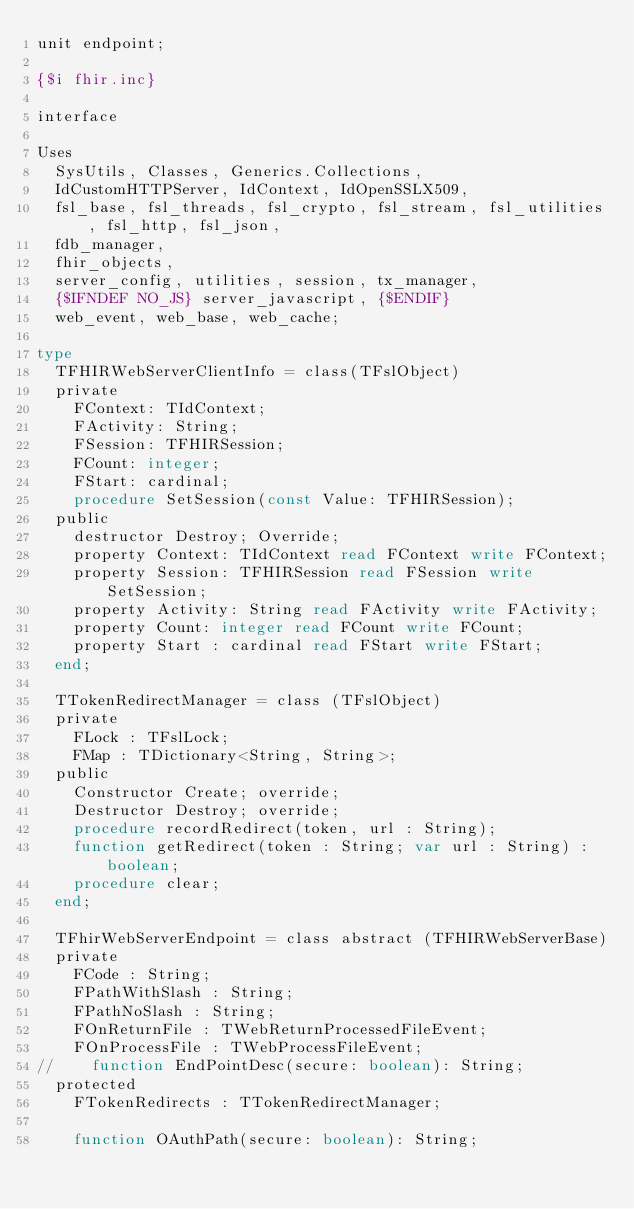<code> <loc_0><loc_0><loc_500><loc_500><_Pascal_>unit endpoint;

{$i fhir.inc}

interface

Uses
  SysUtils, Classes, Generics.Collections,
  IdCustomHTTPServer, IdContext, IdOpenSSLX509,
  fsl_base, fsl_threads, fsl_crypto, fsl_stream, fsl_utilities, fsl_http, fsl_json,
  fdb_manager,
  fhir_objects,
  server_config, utilities, session, tx_manager,
  {$IFNDEF NO_JS} server_javascript, {$ENDIF}
  web_event, web_base, web_cache;

type
  TFHIRWebServerClientInfo = class(TFslObject)
  private
    FContext: TIdContext;
    FActivity: String;
    FSession: TFHIRSession;
    FCount: integer;
    FStart: cardinal;
    procedure SetSession(const Value: TFHIRSession);
  public
    destructor Destroy; Override;
    property Context: TIdContext read FContext write FContext;
    property Session: TFHIRSession read FSession write SetSession;
    property Activity: String read FActivity write FActivity;
    property Count: integer read FCount write FCount;
    property Start : cardinal read FStart write FStart;
  end;

  TTokenRedirectManager = class (TFslObject)
  private
    FLock : TFslLock;
    FMap : TDictionary<String, String>;
  public
    Constructor Create; override;
    Destructor Destroy; override;
    procedure recordRedirect(token, url : String);
    function getRedirect(token : String; var url : String) : boolean;
    procedure clear;
  end;

  TFhirWebServerEndpoint = class abstract (TFHIRWebServerBase)
  private
    FCode : String;
    FPathWithSlash : String;
    FPathNoSlash : String;
    FOnReturnFile : TWebReturnProcessedFileEvent;
    FOnProcessFile : TWebProcessFileEvent;
//    function EndPointDesc(secure: boolean): String;
  protected
    FTokenRedirects : TTokenRedirectManager;

    function OAuthPath(secure: boolean): String;</code> 